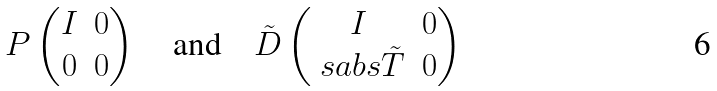<formula> <loc_0><loc_0><loc_500><loc_500>P \begin{pmatrix} I & 0 \\ 0 & 0 \\ \end{pmatrix} \quad \text {and} \quad \tilde { D } \begin{pmatrix} I & 0 \\ \ s a b s { \tilde { T } } & 0 \\ \end{pmatrix}</formula> 